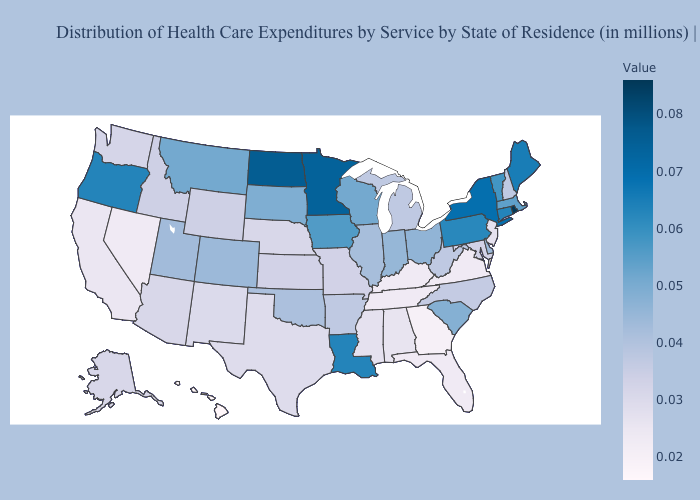Does Oklahoma have a lower value than Pennsylvania?
Write a very short answer. Yes. Does Oklahoma have the lowest value in the USA?
Quick response, please. No. Does Michigan have a higher value than Connecticut?
Quick response, please. No. Does Michigan have the lowest value in the MidWest?
Concise answer only. No. Does Oklahoma have a lower value than Texas?
Answer briefly. No. Does the map have missing data?
Be succinct. No. Does Vermont have a higher value than Rhode Island?
Give a very brief answer. No. 